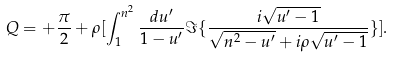Convert formula to latex. <formula><loc_0><loc_0><loc_500><loc_500>Q = + \frac { \pi } { 2 } + \rho [ \int _ { 1 } ^ { n ^ { 2 } } \frac { d u ^ { \prime } } { 1 - u ^ { \prime } } \Im \{ \frac { i \sqrt { u ^ { \prime } - 1 } } { \sqrt { n ^ { 2 } - u ^ { \prime } } + i \rho \sqrt { u ^ { \prime } - 1 } } \} ] .</formula> 